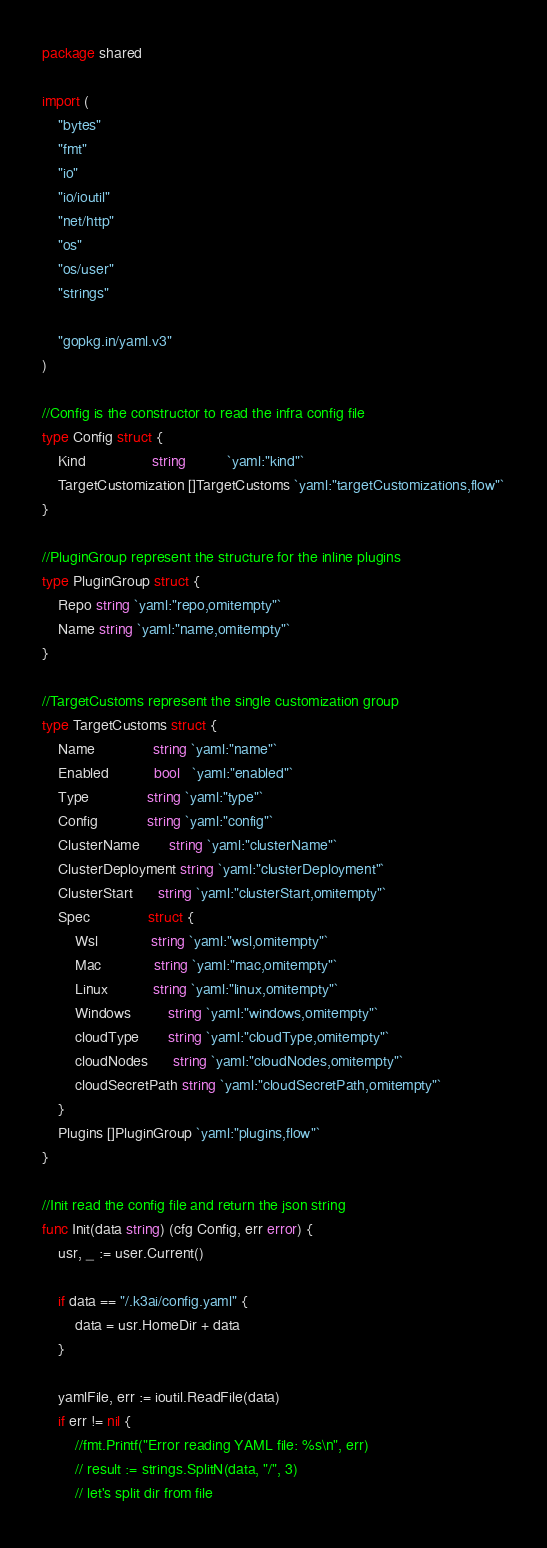<code> <loc_0><loc_0><loc_500><loc_500><_Go_>package shared

import (
	"bytes"
	"fmt"
	"io"
	"io/ioutil"
	"net/http"
	"os"
	"os/user"
	"strings"

	"gopkg.in/yaml.v3"
)

//Config is the constructor to read the infra config file
type Config struct {
	Kind                string          `yaml:"kind"`
	TargetCustomization []TargetCustoms `yaml:"targetCustomizations,flow"`
}

//PluginGroup represent the structure for the inline plugins
type PluginGroup struct {
	Repo string `yaml:"repo,omitempty"`
	Name string `yaml:"name,omitempty"`
}

//TargetCustoms represent the single customization group
type TargetCustoms struct {
	Name              string `yaml:"name"`
	Enabled           bool   `yaml:"enabled"`
	Type              string `yaml:"type"`
	Config            string `yaml:"config"`
	ClusterName       string `yaml:"clusterName"`
	ClusterDeployment string `yaml:"clusterDeployment"`
	ClusterStart      string `yaml:"clusterStart,omitempty"`
	Spec              struct {
		Wsl             string `yaml:"wsl,omitempty"`
		Mac             string `yaml:"mac,omitempty"`
		Linux           string `yaml:"linux,omitempty"`
		Windows         string `yaml:"windows,omitempty"`
		cloudType       string `yaml:"cloudType,omitempty"`
		cloudNodes      string `yaml:"cloudNodes,omitempty"`
		cloudSecretPath string `yaml:"cloudSecretPath,omitempty"`
	}
	Plugins []PluginGroup `yaml:"plugins,flow"`
}

//Init read the config file and return the json string
func Init(data string) (cfg Config, err error) {
	usr, _ := user.Current()

	if data == "/.k3ai/config.yaml" {
		data = usr.HomeDir + data
	}

	yamlFile, err := ioutil.ReadFile(data)
	if err != nil {
		//fmt.Printf("Error reading YAML file: %s\n", err)
		// result := strings.SplitN(data, "/", 3)
		// let's split dir from file</code> 